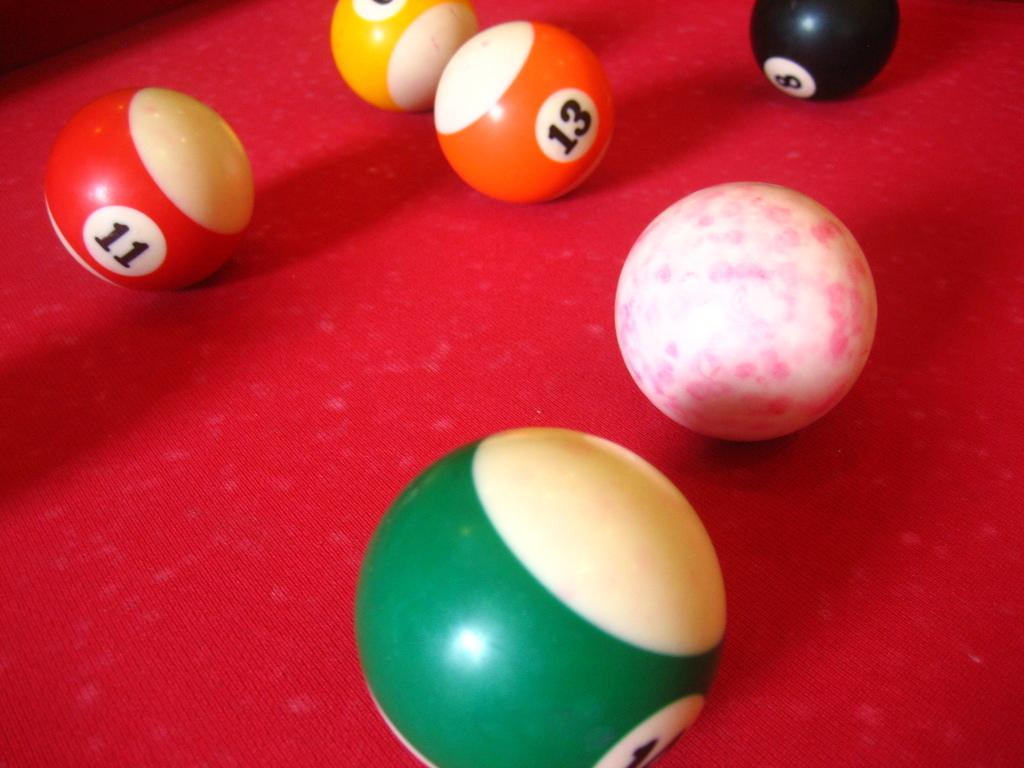What type of balls are visible in the image? There are snooker balls in the image. What color is the object on which the snooker balls are placed? The object is red. What type of offer is being made with the snooker balls in the image? There is no offer being made with the snooker balls in the image; they are simply placed on a red object. 